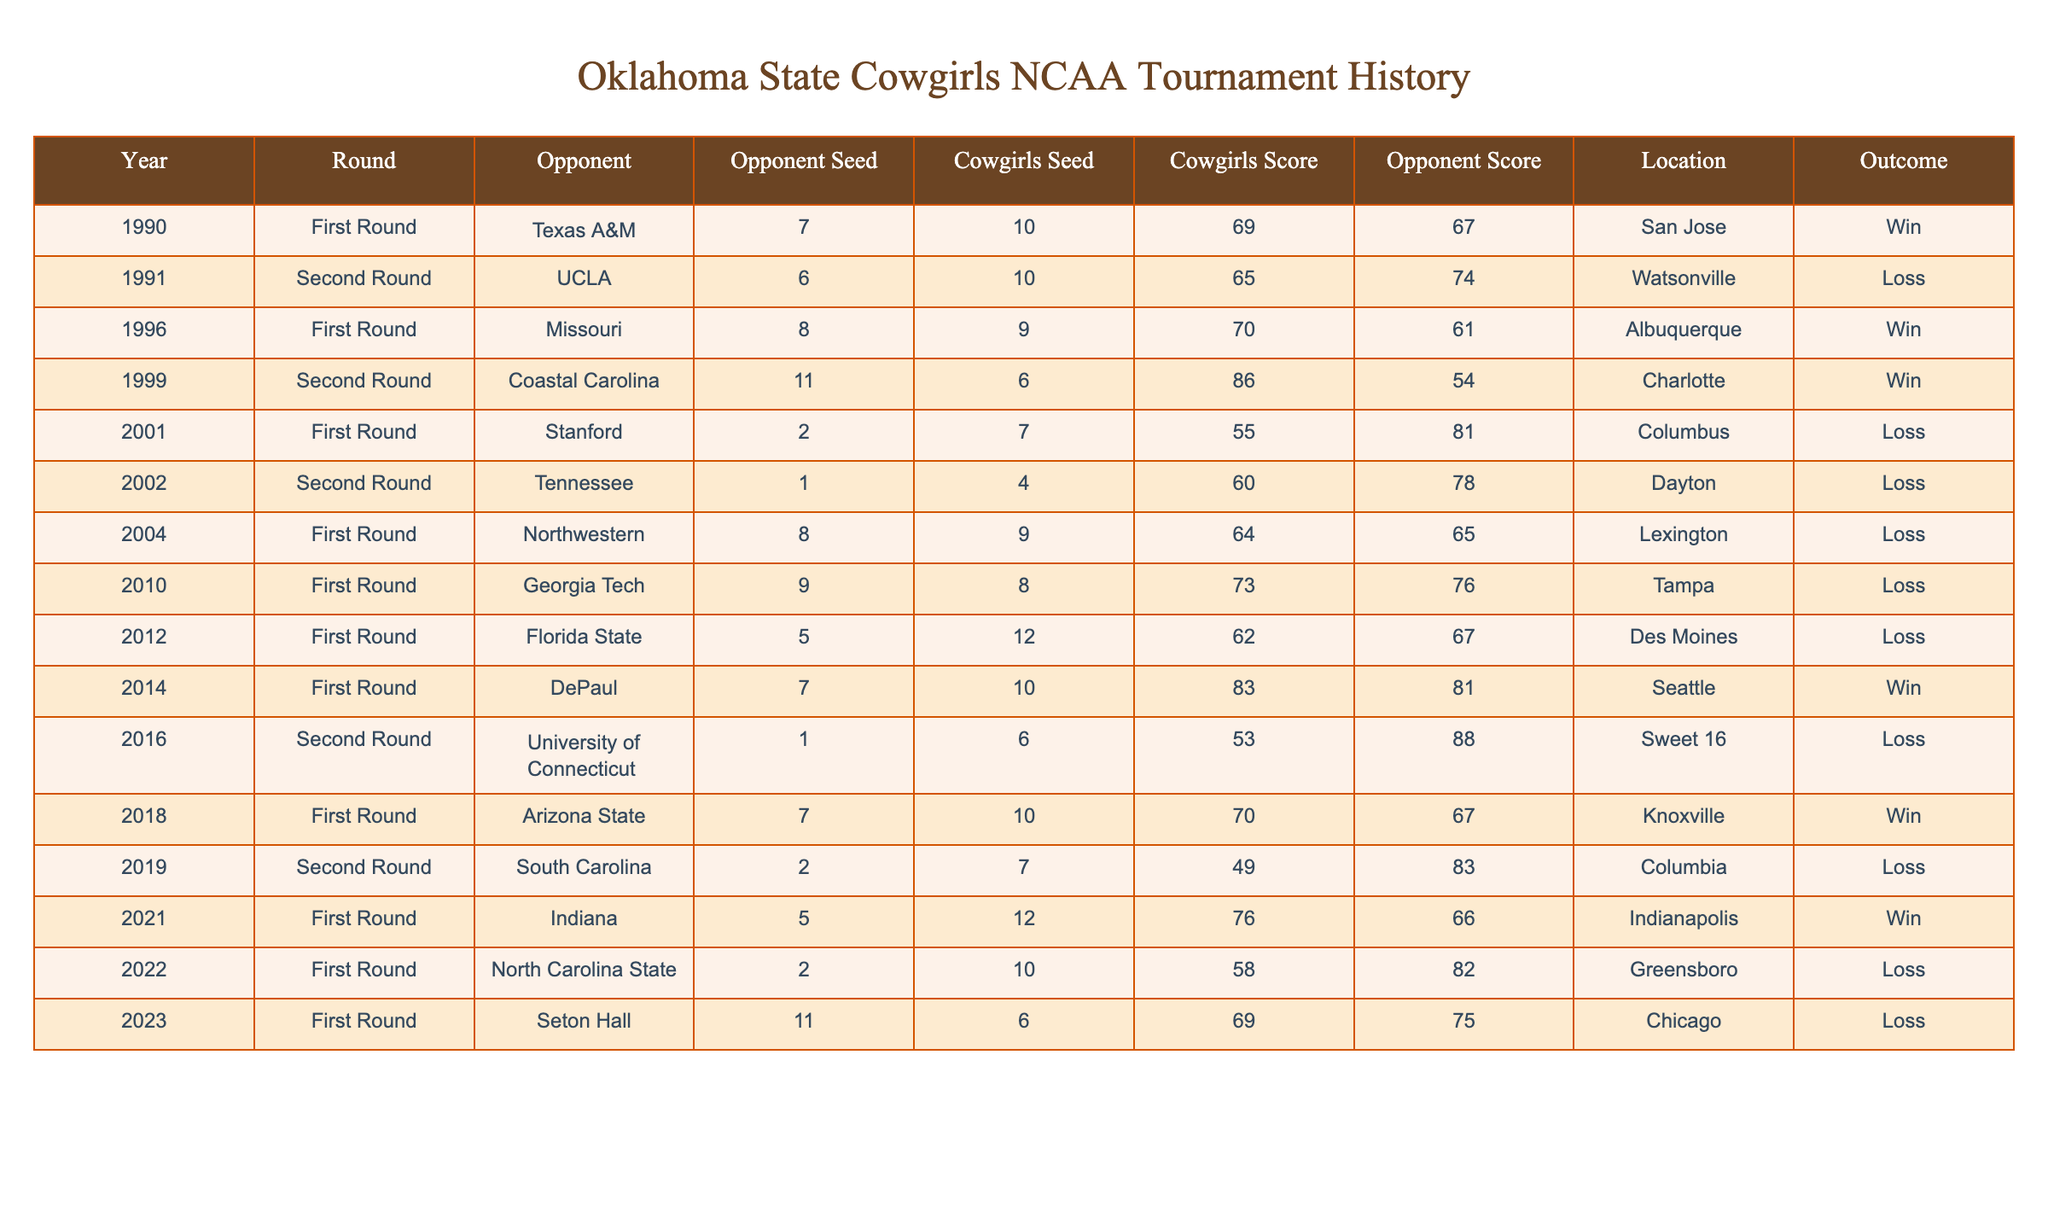What year did the Cowgirls achieve their highest NCAA tournament score? The highest score the Cowgirls achieved in the NCAA tournament was 86 points against Coastal Carolina in 1999.
Answer: 1999 How many NCAA tournament games did the Oklahoma State Cowgirls win? There are a total of 6 wins in the table: 1990, 1996, 1999, 2014, 2018, and 2021.
Answer: 6 What was the average score of the Cowgirls in the NCAA tournament games they won? The scores in wins are 69, 70, 86, 83, 70, and 76, totaling 450 points. There are 6 wins, so the average is 450/6 = 75.
Answer: 75 Did the Cowgirls ever win against a higher-seeded opponent? Yes, the Cowgirls won against the higher-seeded teams in 1996 (Missouri) and 1999 (Coastal Carolina).
Answer: Yes Which opponent did the Cowgirls lose to the most times? The table indicates they lost to Tennessee in 2002 and South Carolina in 2019, but since they only played each opponent once, no opponent stands out for multiple losses.
Answer: None In what round did the Cowgirls play the University of Connecticut, and what was the outcome? The Cowgirls played against the University of Connecticut in the Second Round in 2016 and lost with a score of 53 to 88.
Answer: Loss What is the ratio of wins to losses for the Oklahoma State Cowgirls in the NCAA tournament based on this table? The Cowgirls have 6 wins and 8 losses, giving a ratio of 6:8 which simplifies to 3:4.
Answer: 3:4 Which location hosted the Cowgirls' victory over Texas A&M? The Cowgirls' victory over Texas A&M in 1990 was hosted in San Jose.
Answer: San Jose When was the last time the Cowgirls won a game in the NCAA tournament? The last victory recorded in the table is from 2021 against Indiana in the First Round.
Answer: 2021 How many times did the Cowgirls score over 80 points in the NCAA tournament? The Cowgirls scored over 80 points once in 1999 against Coastal Carolina with a score of 86.
Answer: 1 